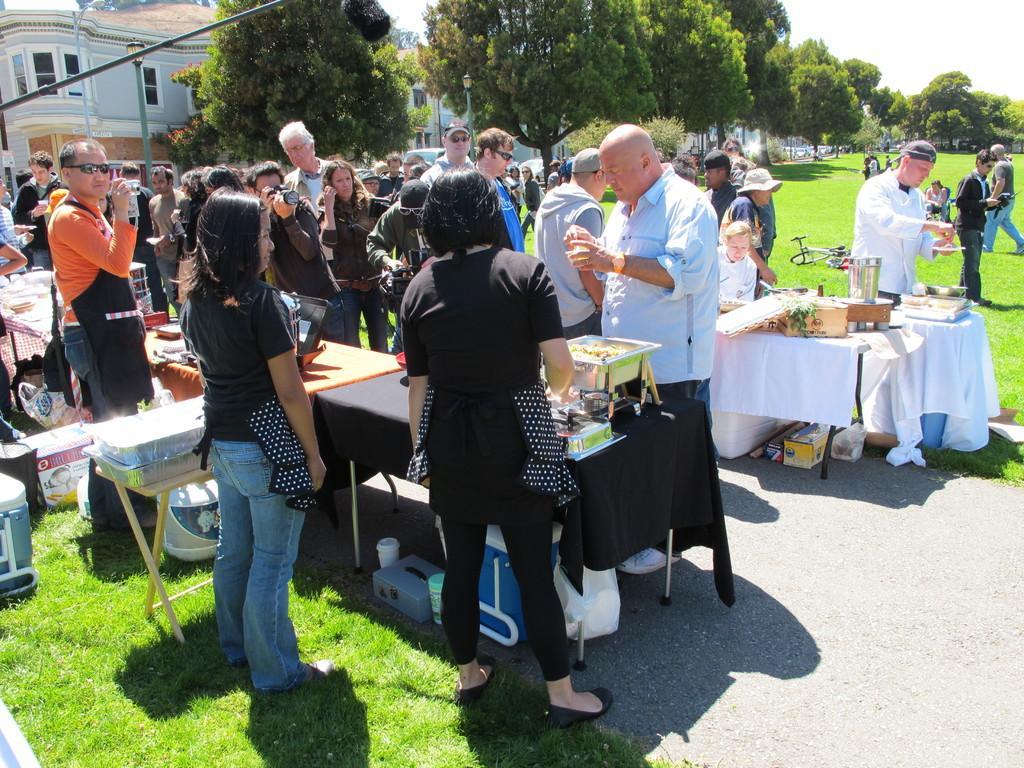What is happening with the group of people in the image? There is a group of people standing in the image. What activity is someone engaged in at the table? Someone is eating food on a table. What can be seen in the distance behind the people and table? There are trees and a building visible in the background of the image. What type of bell can be heard ringing in the image? There is no bell present or audible in the image. Can you see any bones on the table where someone is eating food? There is no mention of bones on the table in the image. 